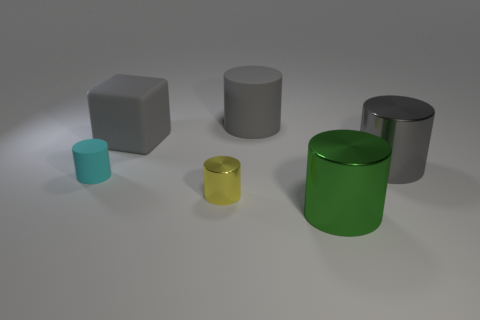Add 1 tiny green matte spheres. How many objects exist? 7 Subtract all big matte cylinders. How many cylinders are left? 4 Subtract all green balls. How many cyan cubes are left? 0 Subtract all rubber cylinders. Subtract all big gray things. How many objects are left? 1 Add 2 tiny matte cylinders. How many tiny matte cylinders are left? 3 Add 5 rubber cylinders. How many rubber cylinders exist? 7 Subtract all green cylinders. How many cylinders are left? 4 Subtract 0 blue cylinders. How many objects are left? 6 Subtract all blocks. How many objects are left? 5 Subtract 1 blocks. How many blocks are left? 0 